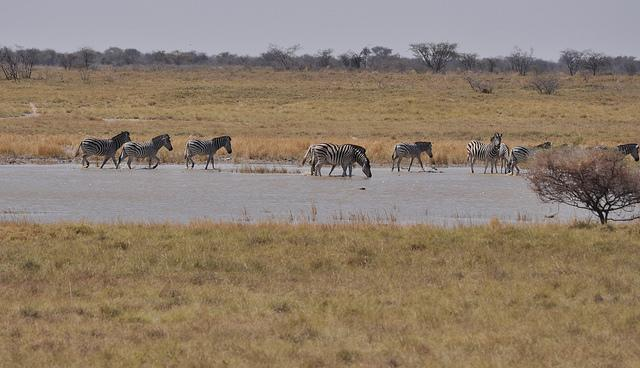What direction are the animals facing? Please explain your reasoning. east. The zebras are facing to the right. 